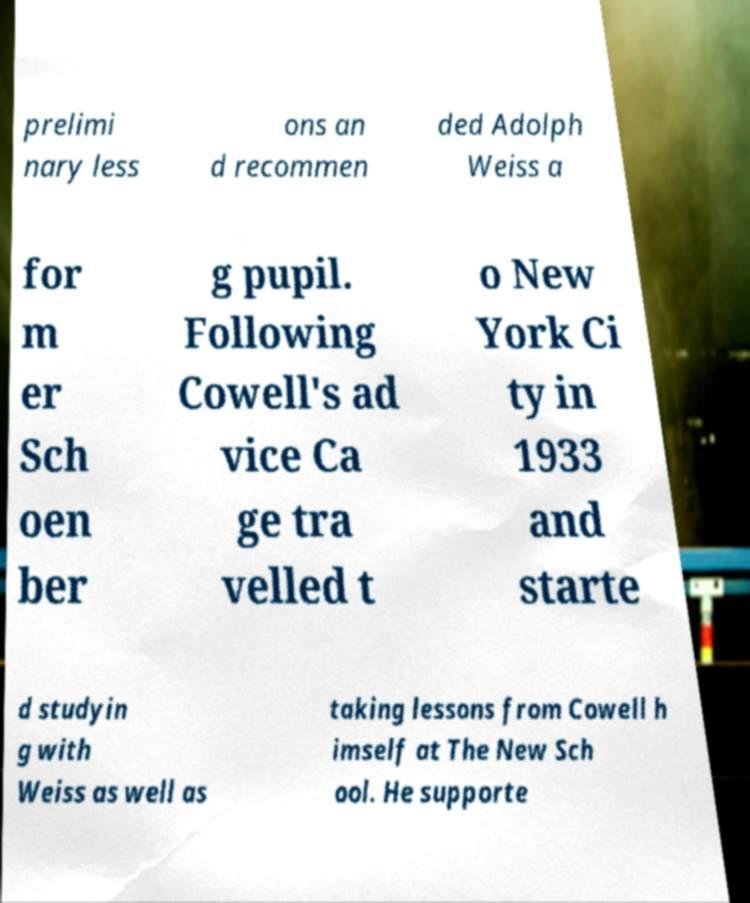I need the written content from this picture converted into text. Can you do that? prelimi nary less ons an d recommen ded Adolph Weiss a for m er Sch oen ber g pupil. Following Cowell's ad vice Ca ge tra velled t o New York Ci ty in 1933 and starte d studyin g with Weiss as well as taking lessons from Cowell h imself at The New Sch ool. He supporte 